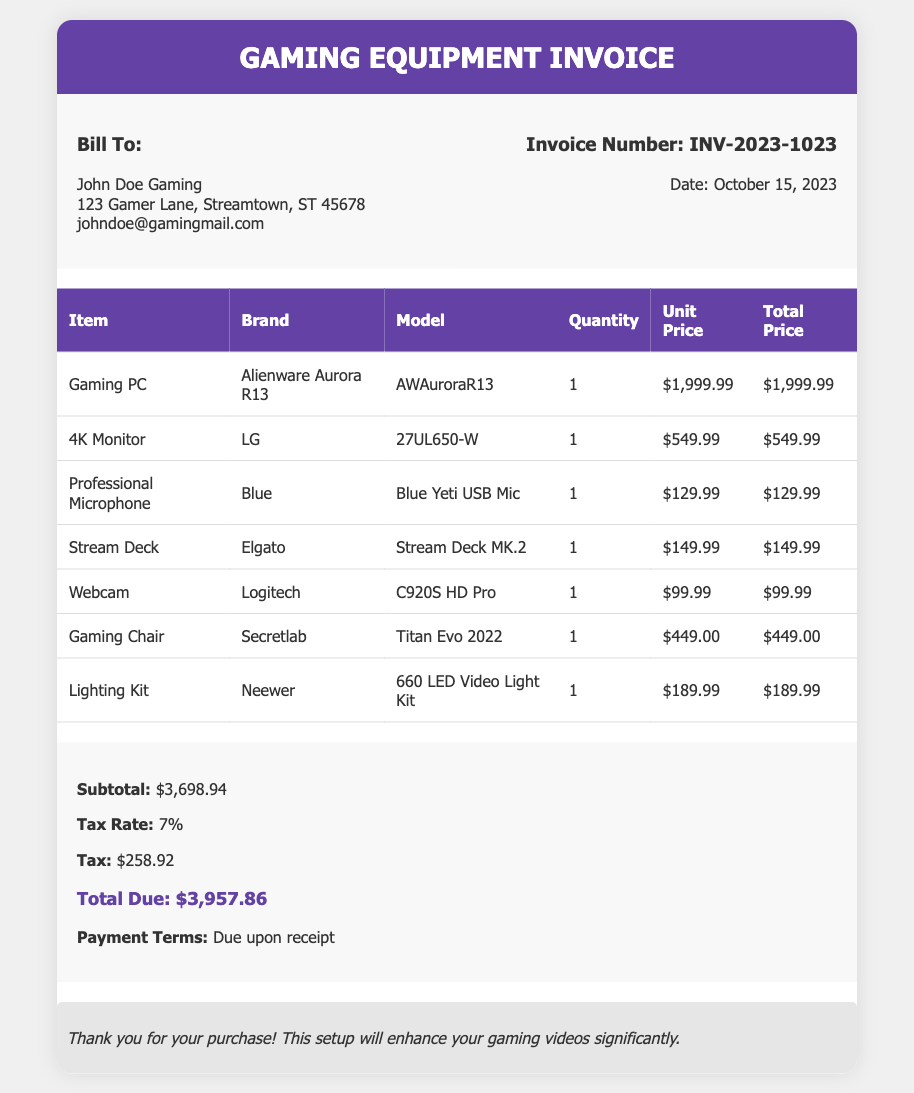What is the invoice number? The invoice number is located in the document under the invoice details section.
Answer: INV-2023-1023 What is the total amount due? The total amount due is listed in the summary section of the document.
Answer: $3,957.86 What is the date of the invoice? The date of the invoice is provided in the invoice details near the invoice number.
Answer: October 15, 2023 Who is the bill to? The billing information specifies the name and address in the bill to section.
Answer: John Doe Gaming What is the subtotal amount? The subtotal is included in the summary as the total before tax.
Answer: $3,698.94 How many items are listed on the invoice? The number of items can be counted from the items listed in the table.
Answer: 7 What is the tax rate applied? The tax rate is mentioned in the summary of the invoice.
Answer: 7% What brand is the Gaming PC? The brand for the Gaming PC is mentioned in the itemized list of equipment.
Answer: Alienware What is mentioned in the notes section? The notes section contains a message regarding the purchase.
Answer: Thank you for your purchase! This setup will enhance your gaming videos significantly 